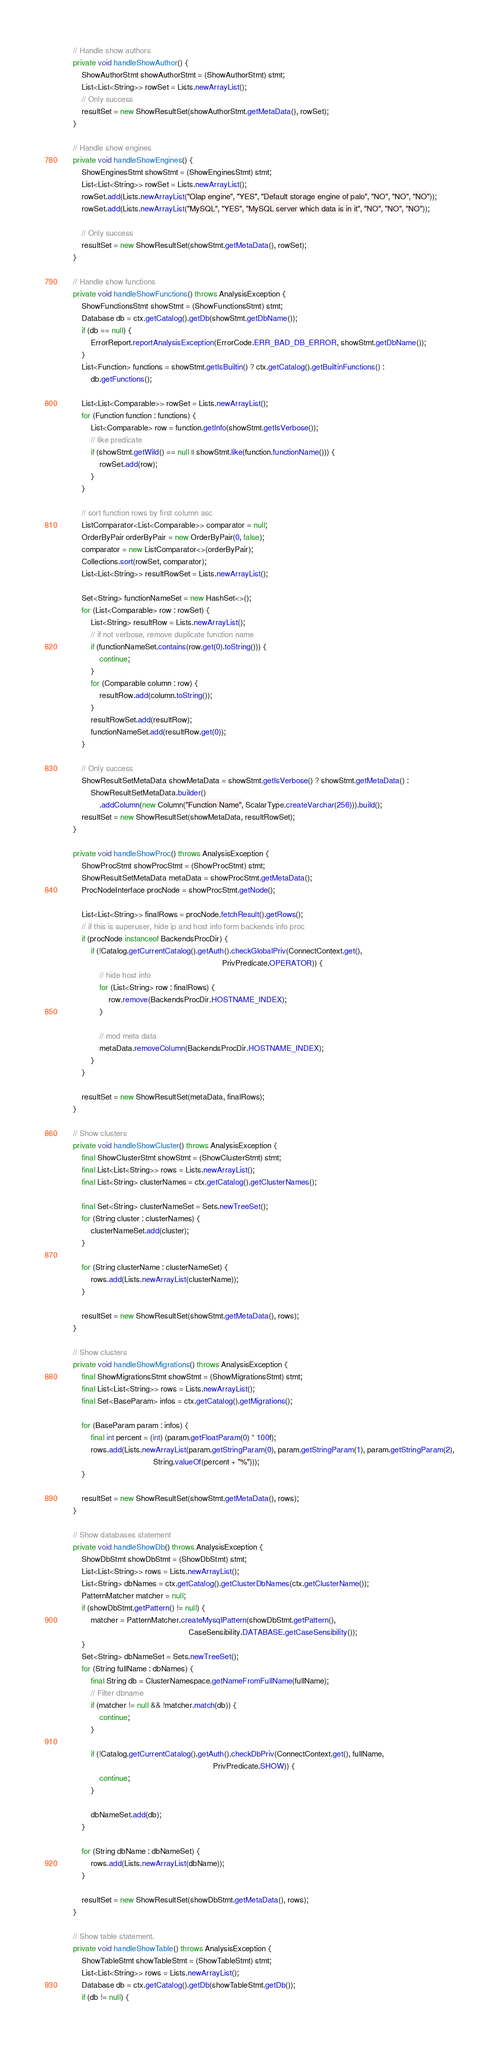<code> <loc_0><loc_0><loc_500><loc_500><_Java_>
    // Handle show authors
    private void handleShowAuthor() {
        ShowAuthorStmt showAuthorStmt = (ShowAuthorStmt) stmt;
        List<List<String>> rowSet = Lists.newArrayList();
        // Only success
        resultSet = new ShowResultSet(showAuthorStmt.getMetaData(), rowSet);
    }

    // Handle show engines
    private void handleShowEngines() {
        ShowEnginesStmt showStmt = (ShowEnginesStmt) stmt;
        List<List<String>> rowSet = Lists.newArrayList();
        rowSet.add(Lists.newArrayList("Olap engine", "YES", "Default storage engine of palo", "NO", "NO", "NO"));
        rowSet.add(Lists.newArrayList("MySQL", "YES", "MySQL server which data is in it", "NO", "NO", "NO"));

        // Only success
        resultSet = new ShowResultSet(showStmt.getMetaData(), rowSet);
    }

    // Handle show functions
    private void handleShowFunctions() throws AnalysisException {
        ShowFunctionsStmt showStmt = (ShowFunctionsStmt) stmt;
        Database db = ctx.getCatalog().getDb(showStmt.getDbName());
        if (db == null) {
            ErrorReport.reportAnalysisException(ErrorCode.ERR_BAD_DB_ERROR, showStmt.getDbName());
        }
        List<Function> functions = showStmt.getIsBuiltin() ? ctx.getCatalog().getBuiltinFunctions() :
            db.getFunctions();

        List<List<Comparable>> rowSet = Lists.newArrayList();
        for (Function function : functions) {
            List<Comparable> row = function.getInfo(showStmt.getIsVerbose());
            // like predicate
            if (showStmt.getWild() == null || showStmt.like(function.functionName())) {
                rowSet.add(row);
            }
        }

        // sort function rows by first column asc
        ListComparator<List<Comparable>> comparator = null;
        OrderByPair orderByPair = new OrderByPair(0, false);
        comparator = new ListComparator<>(orderByPair);
        Collections.sort(rowSet, comparator);
        List<List<String>> resultRowSet = Lists.newArrayList();

        Set<String> functionNameSet = new HashSet<>();
        for (List<Comparable> row : rowSet) {
            List<String> resultRow = Lists.newArrayList();
            // if not verbose, remove duplicate function name
            if (functionNameSet.contains(row.get(0).toString())) {
                continue;
            }
            for (Comparable column : row) {
                resultRow.add(column.toString());
            }
            resultRowSet.add(resultRow);
            functionNameSet.add(resultRow.get(0));
        }

        // Only success
        ShowResultSetMetaData showMetaData = showStmt.getIsVerbose() ? showStmt.getMetaData() :
            ShowResultSetMetaData.builder()
                .addColumn(new Column("Function Name", ScalarType.createVarchar(256))).build();
        resultSet = new ShowResultSet(showMetaData, resultRowSet);
    }

    private void handleShowProc() throws AnalysisException {
        ShowProcStmt showProcStmt = (ShowProcStmt) stmt;
        ShowResultSetMetaData metaData = showProcStmt.getMetaData();
        ProcNodeInterface procNode = showProcStmt.getNode();

        List<List<String>> finalRows = procNode.fetchResult().getRows();
        // if this is superuser, hide ip and host info form backends info proc
        if (procNode instanceof BackendsProcDir) {
            if (!Catalog.getCurrentCatalog().getAuth().checkGlobalPriv(ConnectContext.get(),
                                                                       PrivPredicate.OPERATOR)) {
                // hide host info
                for (List<String> row : finalRows) {
                    row.remove(BackendsProcDir.HOSTNAME_INDEX);
                }

                // mod meta data
                metaData.removeColumn(BackendsProcDir.HOSTNAME_INDEX);
            }
        }

        resultSet = new ShowResultSet(metaData, finalRows);
    }

    // Show clusters
    private void handleShowCluster() throws AnalysisException {
        final ShowClusterStmt showStmt = (ShowClusterStmt) stmt;
        final List<List<String>> rows = Lists.newArrayList();
        final List<String> clusterNames = ctx.getCatalog().getClusterNames();

        final Set<String> clusterNameSet = Sets.newTreeSet();
        for (String cluster : clusterNames) {
            clusterNameSet.add(cluster);
        }

        for (String clusterName : clusterNameSet) {
            rows.add(Lists.newArrayList(clusterName));
        }

        resultSet = new ShowResultSet(showStmt.getMetaData(), rows);
    }

    // Show clusters
    private void handleShowMigrations() throws AnalysisException {
        final ShowMigrationsStmt showStmt = (ShowMigrationsStmt) stmt;
        final List<List<String>> rows = Lists.newArrayList();
        final Set<BaseParam> infos = ctx.getCatalog().getMigrations();

        for (BaseParam param : infos) {
            final int percent = (int) (param.getFloatParam(0) * 100f);
            rows.add(Lists.newArrayList(param.getStringParam(0), param.getStringParam(1), param.getStringParam(2),
                                        String.valueOf(percent + "%")));
        }

        resultSet = new ShowResultSet(showStmt.getMetaData(), rows);
    }

    // Show databases statement
    private void handleShowDb() throws AnalysisException {
        ShowDbStmt showDbStmt = (ShowDbStmt) stmt;
        List<List<String>> rows = Lists.newArrayList();
        List<String> dbNames = ctx.getCatalog().getClusterDbNames(ctx.getClusterName());
        PatternMatcher matcher = null;
        if (showDbStmt.getPattern() != null) {
            matcher = PatternMatcher.createMysqlPattern(showDbStmt.getPattern(),
                                                        CaseSensibility.DATABASE.getCaseSensibility());
        }
        Set<String> dbNameSet = Sets.newTreeSet();
        for (String fullName : dbNames) {
            final String db = ClusterNamespace.getNameFromFullName(fullName);
            // Filter dbname
            if (matcher != null && !matcher.match(db)) {
                continue;
            }

            if (!Catalog.getCurrentCatalog().getAuth().checkDbPriv(ConnectContext.get(), fullName,
                                                                   PrivPredicate.SHOW)) {
                continue;
            }

            dbNameSet.add(db);
        }

        for (String dbName : dbNameSet) {
            rows.add(Lists.newArrayList(dbName));
        }

        resultSet = new ShowResultSet(showDbStmt.getMetaData(), rows);
    }

    // Show table statement.
    private void handleShowTable() throws AnalysisException {
        ShowTableStmt showTableStmt = (ShowTableStmt) stmt;
        List<List<String>> rows = Lists.newArrayList();
        Database db = ctx.getCatalog().getDb(showTableStmt.getDb());
        if (db != null) {</code> 